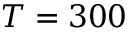<formula> <loc_0><loc_0><loc_500><loc_500>T = 3 0 0</formula> 